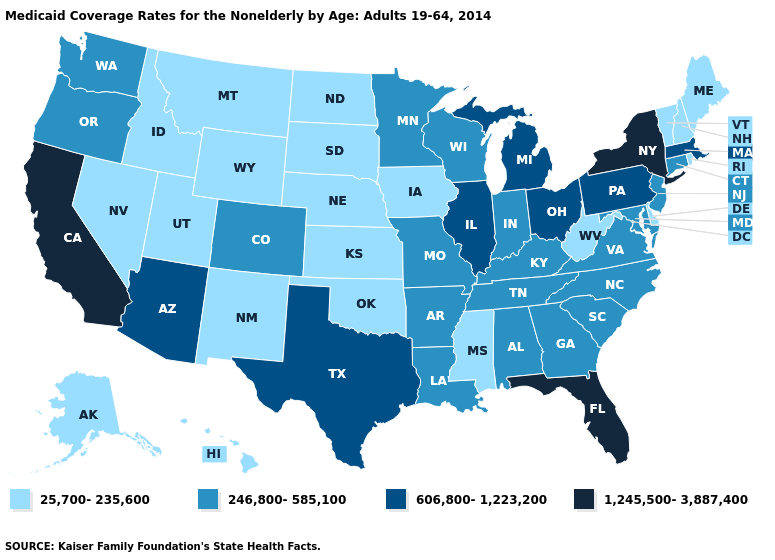What is the lowest value in states that border Maryland?
Concise answer only. 25,700-235,600. What is the value of Georgia?
Quick response, please. 246,800-585,100. What is the lowest value in states that border New York?
Write a very short answer. 25,700-235,600. Name the states that have a value in the range 246,800-585,100?
Give a very brief answer. Alabama, Arkansas, Colorado, Connecticut, Georgia, Indiana, Kentucky, Louisiana, Maryland, Minnesota, Missouri, New Jersey, North Carolina, Oregon, South Carolina, Tennessee, Virginia, Washington, Wisconsin. Name the states that have a value in the range 246,800-585,100?
Quick response, please. Alabama, Arkansas, Colorado, Connecticut, Georgia, Indiana, Kentucky, Louisiana, Maryland, Minnesota, Missouri, New Jersey, North Carolina, Oregon, South Carolina, Tennessee, Virginia, Washington, Wisconsin. Which states have the lowest value in the MidWest?
Give a very brief answer. Iowa, Kansas, Nebraska, North Dakota, South Dakota. Does the map have missing data?
Give a very brief answer. No. Does Nebraska have the highest value in the MidWest?
Short answer required. No. Name the states that have a value in the range 1,245,500-3,887,400?
Short answer required. California, Florida, New York. What is the highest value in the USA?
Be succinct. 1,245,500-3,887,400. Name the states that have a value in the range 1,245,500-3,887,400?
Keep it brief. California, Florida, New York. Does Connecticut have a lower value than Nebraska?
Write a very short answer. No. What is the value of Florida?
Keep it brief. 1,245,500-3,887,400. What is the lowest value in states that border Wisconsin?
Give a very brief answer. 25,700-235,600. 